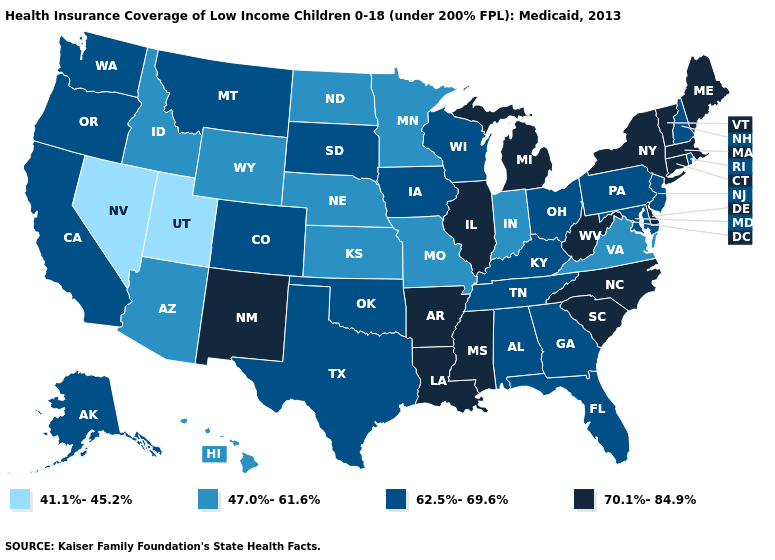What is the value of West Virginia?
Concise answer only. 70.1%-84.9%. Does Colorado have a higher value than Wyoming?
Keep it brief. Yes. What is the highest value in the MidWest ?
Answer briefly. 70.1%-84.9%. Among the states that border Nevada , does Arizona have the lowest value?
Write a very short answer. No. Name the states that have a value in the range 62.5%-69.6%?
Be succinct. Alabama, Alaska, California, Colorado, Florida, Georgia, Iowa, Kentucky, Maryland, Montana, New Hampshire, New Jersey, Ohio, Oklahoma, Oregon, Pennsylvania, Rhode Island, South Dakota, Tennessee, Texas, Washington, Wisconsin. Which states have the lowest value in the USA?
Keep it brief. Nevada, Utah. Does Arkansas have the highest value in the USA?
Short answer required. Yes. Name the states that have a value in the range 70.1%-84.9%?
Be succinct. Arkansas, Connecticut, Delaware, Illinois, Louisiana, Maine, Massachusetts, Michigan, Mississippi, New Mexico, New York, North Carolina, South Carolina, Vermont, West Virginia. What is the lowest value in the MidWest?
Write a very short answer. 47.0%-61.6%. What is the value of California?
Concise answer only. 62.5%-69.6%. Name the states that have a value in the range 41.1%-45.2%?
Quick response, please. Nevada, Utah. Does Minnesota have the lowest value in the MidWest?
Concise answer only. Yes. Name the states that have a value in the range 62.5%-69.6%?
Give a very brief answer. Alabama, Alaska, California, Colorado, Florida, Georgia, Iowa, Kentucky, Maryland, Montana, New Hampshire, New Jersey, Ohio, Oklahoma, Oregon, Pennsylvania, Rhode Island, South Dakota, Tennessee, Texas, Washington, Wisconsin. What is the lowest value in the USA?
Be succinct. 41.1%-45.2%. 